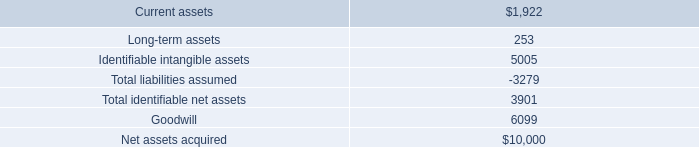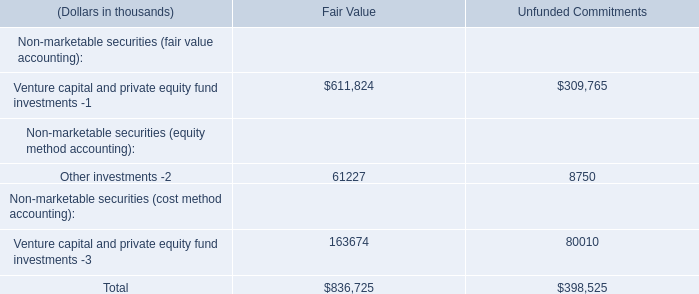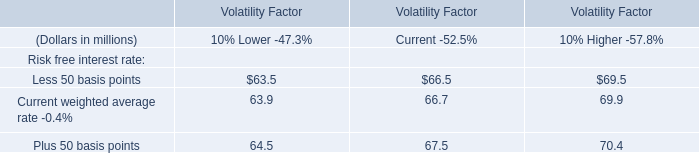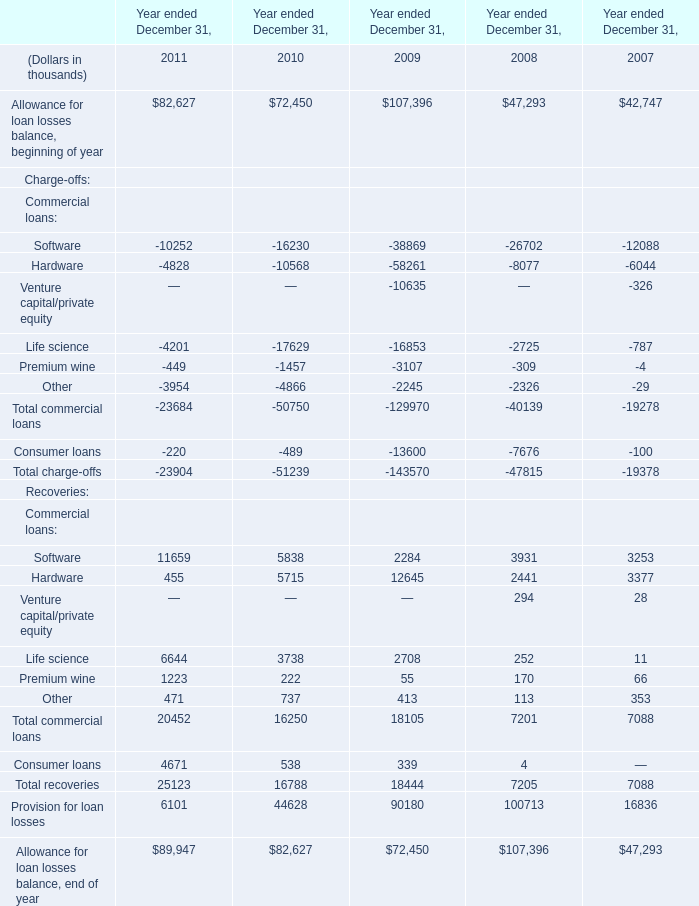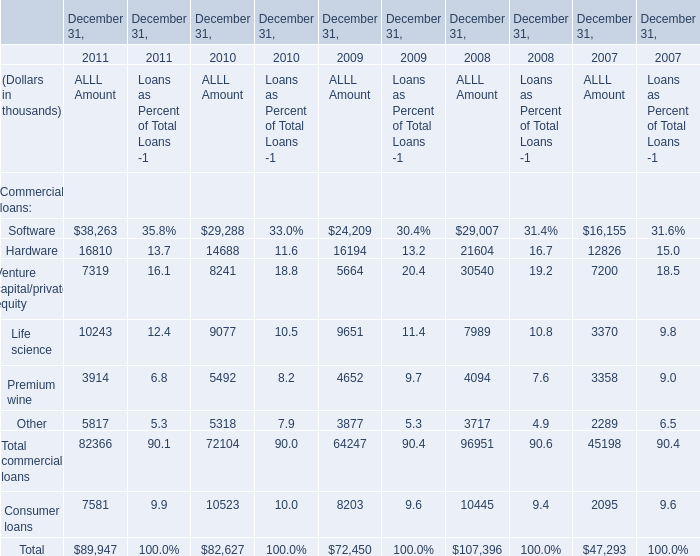What is the growing rate of Total charge-offs in the years with the least Life science? 
Computations: ((-23904 + 51239) / -51239)
Answer: -0.53348. 